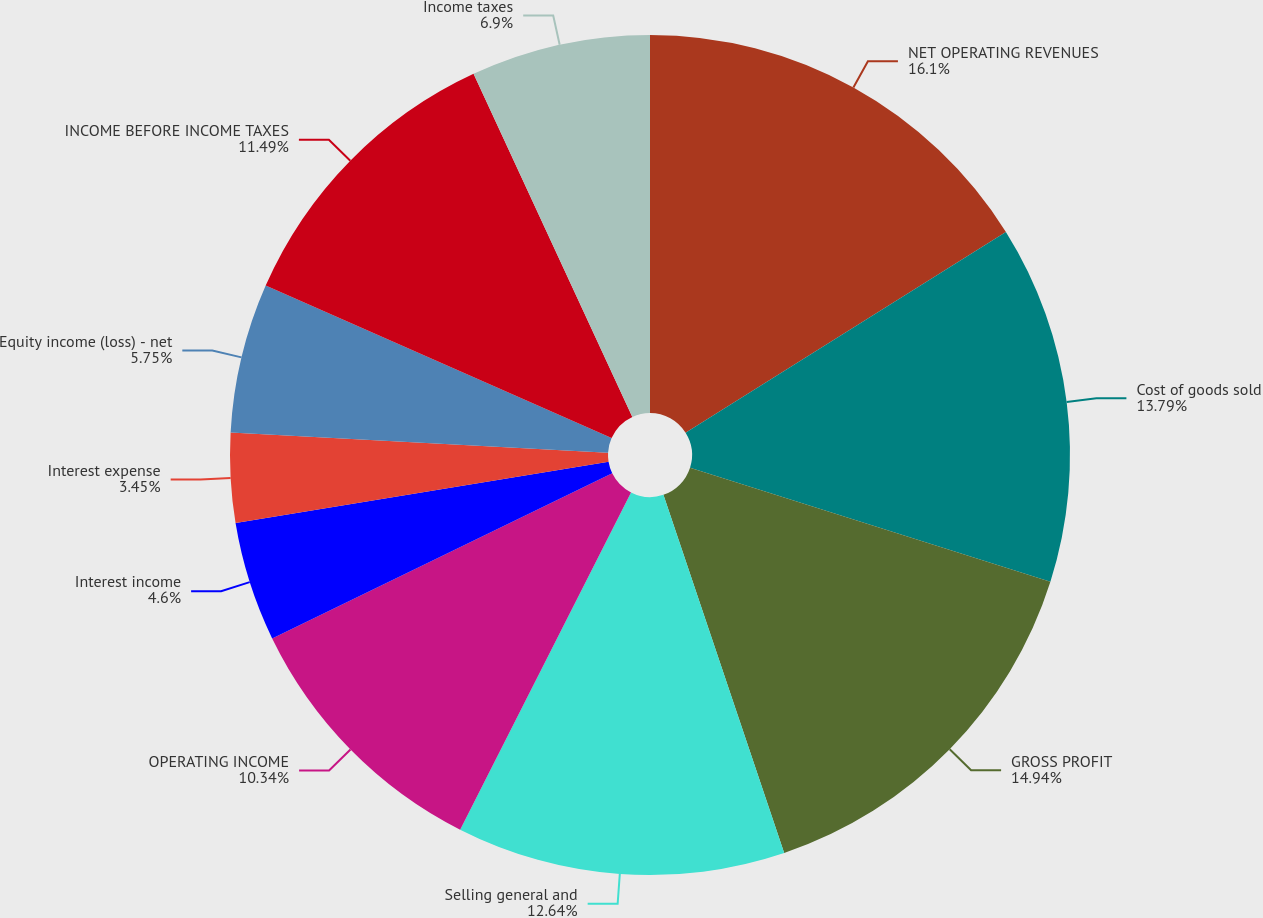Convert chart to OTSL. <chart><loc_0><loc_0><loc_500><loc_500><pie_chart><fcel>NET OPERATING REVENUES<fcel>Cost of goods sold<fcel>GROSS PROFIT<fcel>Selling general and<fcel>OPERATING INCOME<fcel>Interest income<fcel>Interest expense<fcel>Equity income (loss) - net<fcel>INCOME BEFORE INCOME TAXES<fcel>Income taxes<nl><fcel>16.09%<fcel>13.79%<fcel>14.94%<fcel>12.64%<fcel>10.34%<fcel>4.6%<fcel>3.45%<fcel>5.75%<fcel>11.49%<fcel>6.9%<nl></chart> 